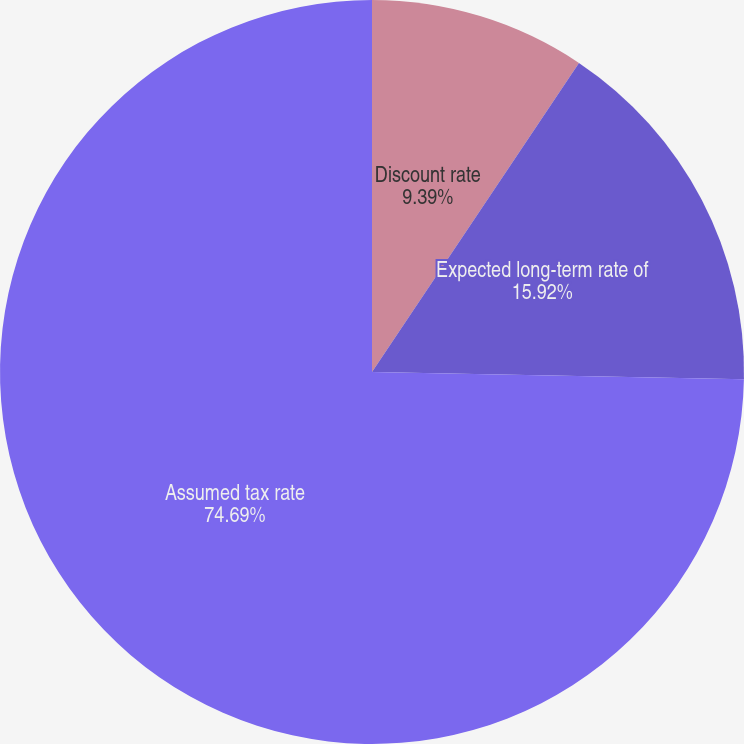Convert chart to OTSL. <chart><loc_0><loc_0><loc_500><loc_500><pie_chart><fcel>Discount rate<fcel>Expected long-term rate of<fcel>Assumed tax rate<nl><fcel>9.39%<fcel>15.92%<fcel>74.69%<nl></chart> 